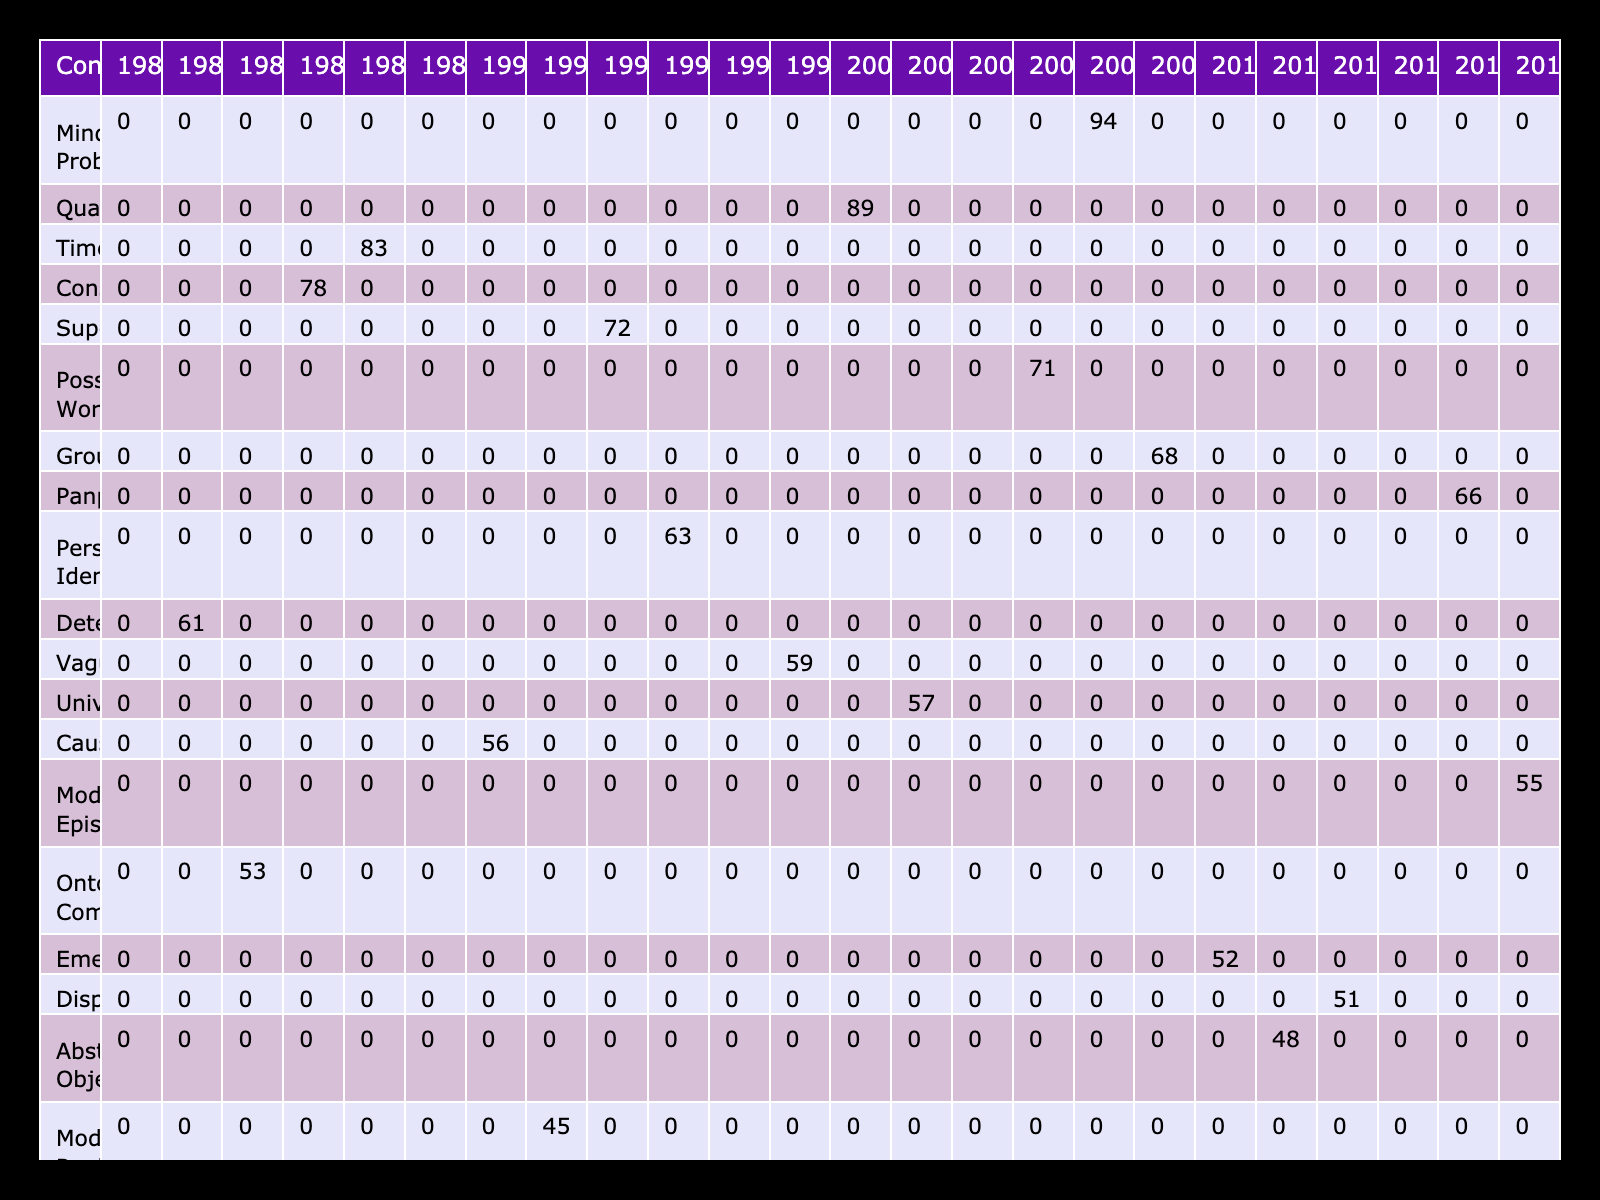What is the highest number of occurrences for a metaphysical concept in the year 2005? In 2005, the concept with the highest occurrences listed is "Possible Worlds" with 71 occurrences.
Answer: 71 Which journal published the concept "Mind-Body Problem"? The concept "Mind-Body Problem" was published in "The Journal of Philosophy." This information can be found directly in the table under the corresponding concept.
Answer: The Journal of Philosophy What is the total number of occurrences for the concept "Consciousness" across all years? To find this, we look at the table and see that "Consciousness" has 78 occurrences in the year 1985. Since this concept is only recorded once, the total occurrences equal 78.
Answer: 78 Is there a concept that appears more than 90 times in the table? By reviewing the occurrences for each concept, we find that the "Mind-Body Problem" has the highest occurrence at 94, which confirms that yes, there is at least one concept that appears more than 90 times.
Answer: Yes What is the average number of occurrences for the concept "Qualia" in its published year? "Qualia" appears in the year 2000 with 89 occurrences. Since there's only one year, the average calculation is straightforward: the occurrences for "Qualia" is 89/1 = 89.
Answer: 89 Which concept experienced a decline in occurrences from 2000 to 2015? By examining the years 2000 and 2015, we find that "Qualia" has 89 occurrences in 2000, while "Substance Dualism" has 37 occurrences in 2015. Therefore, "Substance Dualism" shows a decline in occurrences during this period.
Answer: Substance Dualism What concept has the lowest occurrences in the table and what is that number? Reviewing the table, "Substance Dualism" has the lowest occurrences with 37. This is derived by comparing the occurrences of all listed concepts in the table.
Answer: 37 How many different concepts were published in the journal "Nous"? In the table, we see that "Personal Identity" and "Supervenience" are both associated with the journal "Nous." This gives us a total of 2 different concepts published in this journal.
Answer: 2 What is the difference in occurrences between the concept "Free Will" in 1980 and "Determinism" in 1982? The occurrences for "Free Will" in 1980 are 42, and for "Determinism" in 1982, it is 61. The difference is calculated by subtracting 42 from 61, yielding a result of 19 occurrences.
Answer: 19 